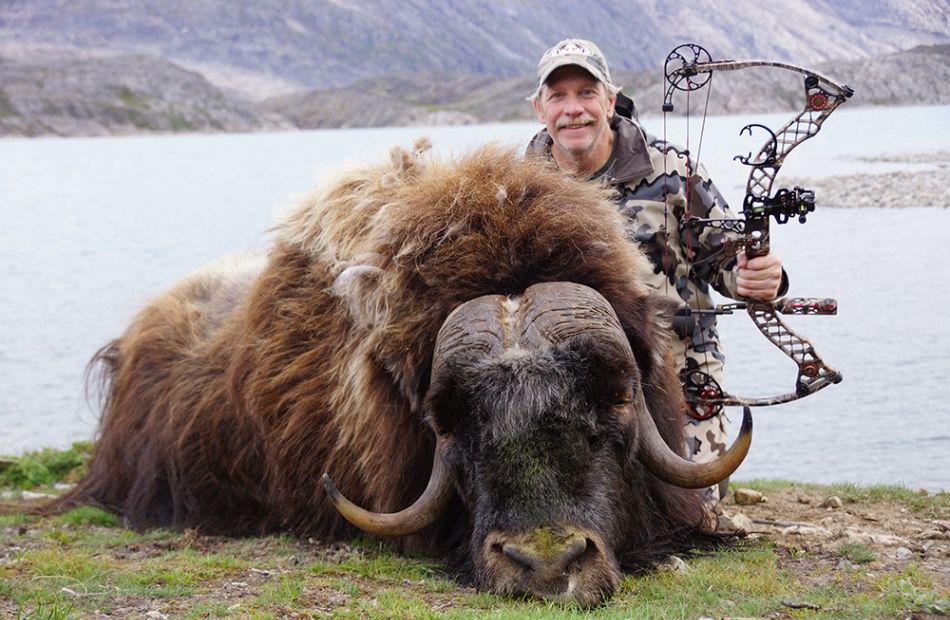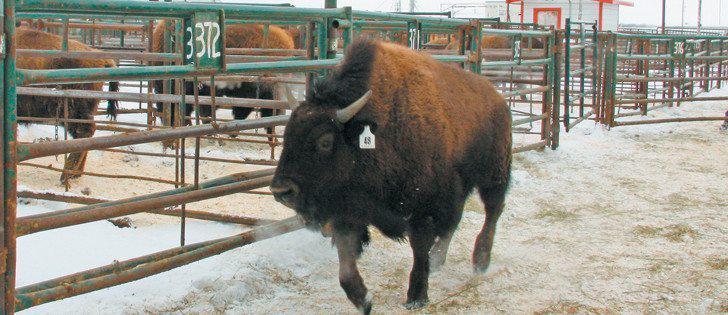The first image is the image on the left, the second image is the image on the right. Analyze the images presented: Is the assertion "A single bull is walking past a metal fence in the image on the right." valid? Answer yes or no. Yes. The first image is the image on the left, the second image is the image on the right. Given the left and right images, does the statement "An image shows at least one shaggy buffalo standing in a field in front of blue mountains, with fence posts on the right behind the animal." hold true? Answer yes or no. No. 